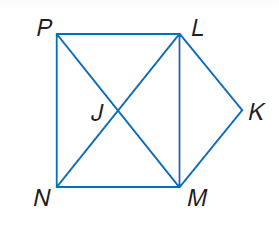Answer the mathemtical geometry problem and directly provide the correct option letter.
Question: Use rectangle L M N P, parallelogram L K M J to solve the problem. If m \angle P L K = 110, find m \angle L K M.
Choices: A: 45 B: 70 C: 110 D: 140 D 